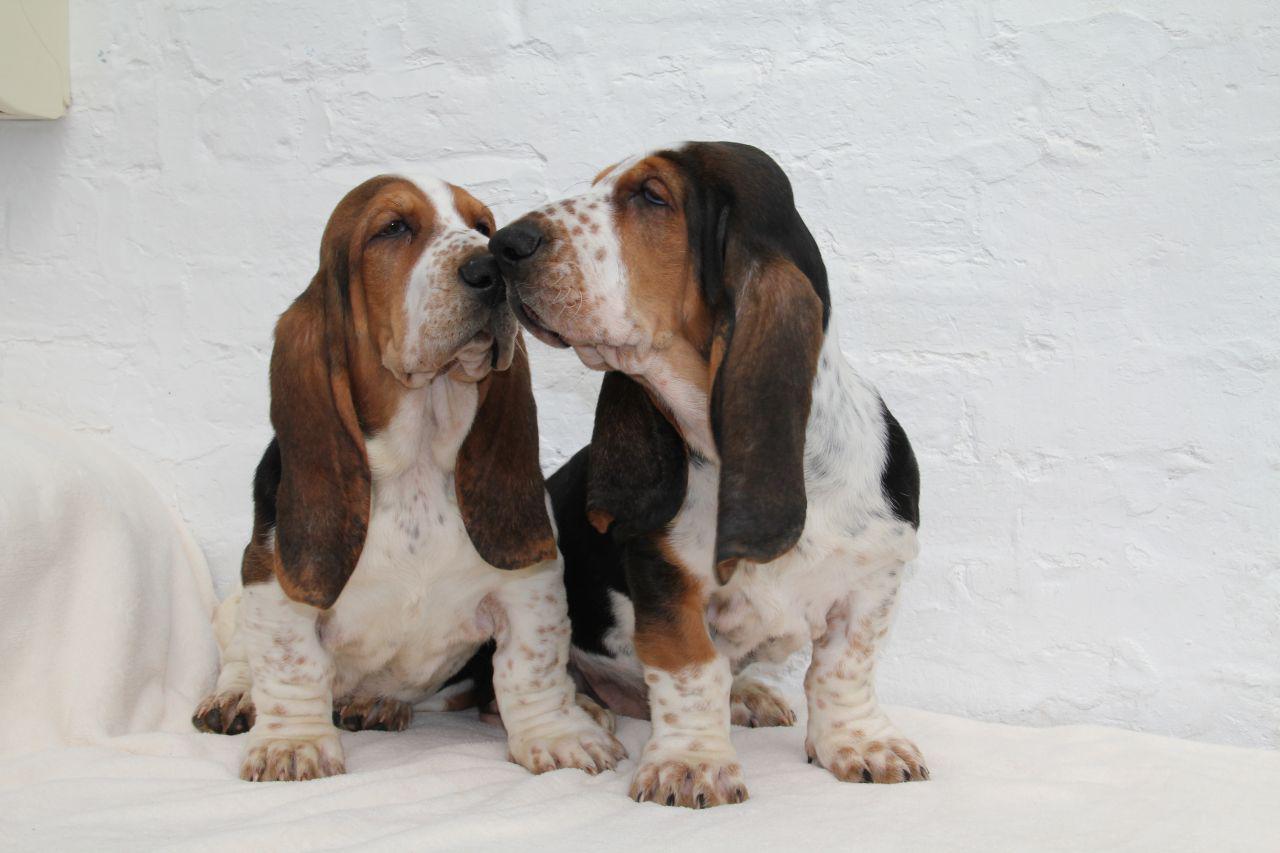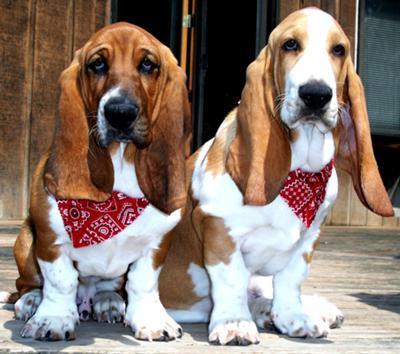The first image is the image on the left, the second image is the image on the right. Given the left and right images, does the statement "There is one image that includes a number of basset hounds that is now two." hold true? Answer yes or no. No. The first image is the image on the left, the second image is the image on the right. Analyze the images presented: Is the assertion "All dogs are in the grass." valid? Answer yes or no. No. 